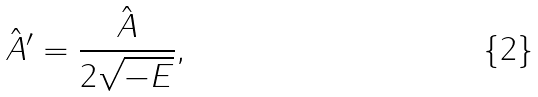<formula> <loc_0><loc_0><loc_500><loc_500>\hat { A } ^ { \prime } = \frac { \hat { A } } { 2 \sqrt { - E } } ,</formula> 